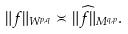Convert formula to latex. <formula><loc_0><loc_0><loc_500><loc_500>\| f \| _ { W ^ { p , q } } \asymp \| \widehat { f } \| _ { M ^ { q , p } } .</formula> 